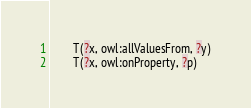Convert code to text. <code><loc_0><loc_0><loc_500><loc_500><_Python_>        T(?x, owl:allValuesFrom, ?y)
        T(?x, owl:onProperty, ?p)</code> 